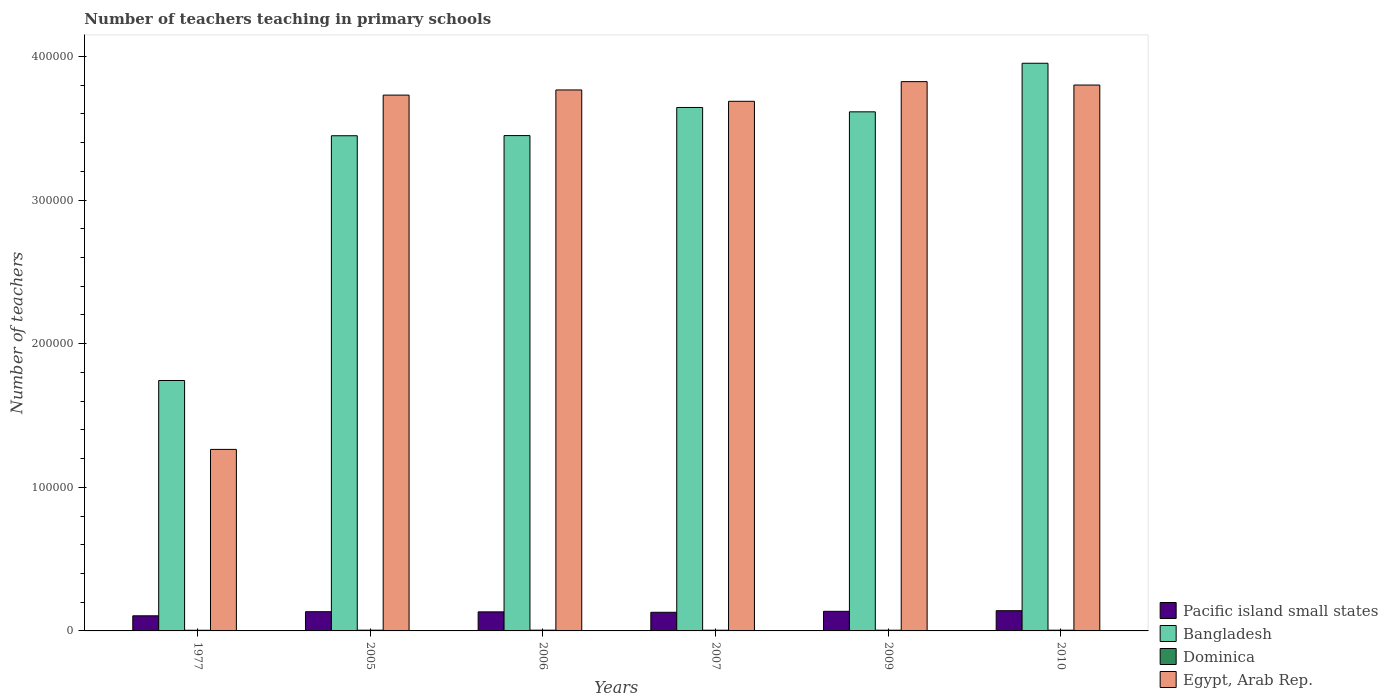How many groups of bars are there?
Provide a short and direct response. 6. Are the number of bars per tick equal to the number of legend labels?
Give a very brief answer. Yes. Are the number of bars on each tick of the X-axis equal?
Your response must be concise. Yes. How many bars are there on the 5th tick from the left?
Your answer should be very brief. 4. What is the label of the 5th group of bars from the left?
Ensure brevity in your answer.  2009. What is the number of teachers teaching in primary schools in Dominica in 2010?
Provide a short and direct response. 508. Across all years, what is the maximum number of teachers teaching in primary schools in Pacific island small states?
Your answer should be very brief. 1.41e+04. Across all years, what is the minimum number of teachers teaching in primary schools in Egypt, Arab Rep.?
Give a very brief answer. 1.26e+05. In which year was the number of teachers teaching in primary schools in Bangladesh maximum?
Keep it short and to the point. 2010. What is the total number of teachers teaching in primary schools in Dominica in the graph?
Provide a short and direct response. 3015. What is the difference between the number of teachers teaching in primary schools in Egypt, Arab Rep. in 1977 and that in 2010?
Keep it short and to the point. -2.54e+05. What is the difference between the number of teachers teaching in primary schools in Egypt, Arab Rep. in 2010 and the number of teachers teaching in primary schools in Pacific island small states in 2009?
Ensure brevity in your answer.  3.66e+05. What is the average number of teachers teaching in primary schools in Pacific island small states per year?
Make the answer very short. 1.30e+04. In the year 2010, what is the difference between the number of teachers teaching in primary schools in Egypt, Arab Rep. and number of teachers teaching in primary schools in Dominica?
Offer a terse response. 3.80e+05. What is the ratio of the number of teachers teaching in primary schools in Pacific island small states in 1977 to that in 2009?
Offer a very short reply. 0.77. Is the number of teachers teaching in primary schools in Dominica in 2006 less than that in 2009?
Your answer should be compact. No. Is the difference between the number of teachers teaching in primary schools in Egypt, Arab Rep. in 2005 and 2010 greater than the difference between the number of teachers teaching in primary schools in Dominica in 2005 and 2010?
Ensure brevity in your answer.  No. What is the difference between the highest and the second highest number of teachers teaching in primary schools in Pacific island small states?
Make the answer very short. 437.17. What is the difference between the highest and the lowest number of teachers teaching in primary schools in Dominica?
Offer a terse response. 57. What does the 1st bar from the left in 2007 represents?
Provide a short and direct response. Pacific island small states. What does the 1st bar from the right in 1977 represents?
Offer a terse response. Egypt, Arab Rep. Is it the case that in every year, the sum of the number of teachers teaching in primary schools in Dominica and number of teachers teaching in primary schools in Egypt, Arab Rep. is greater than the number of teachers teaching in primary schools in Bangladesh?
Give a very brief answer. No. How many bars are there?
Make the answer very short. 24. How many years are there in the graph?
Keep it short and to the point. 6. Does the graph contain any zero values?
Offer a very short reply. No. Where does the legend appear in the graph?
Your response must be concise. Bottom right. How many legend labels are there?
Make the answer very short. 4. How are the legend labels stacked?
Give a very brief answer. Vertical. What is the title of the graph?
Your response must be concise. Number of teachers teaching in primary schools. What is the label or title of the Y-axis?
Your response must be concise. Number of teachers. What is the Number of teachers in Pacific island small states in 1977?
Ensure brevity in your answer.  1.05e+04. What is the Number of teachers of Bangladesh in 1977?
Your answer should be very brief. 1.74e+05. What is the Number of teachers in Dominica in 1977?
Keep it short and to the point. 462. What is the Number of teachers in Egypt, Arab Rep. in 1977?
Your response must be concise. 1.26e+05. What is the Number of teachers of Pacific island small states in 2005?
Provide a succinct answer. 1.34e+04. What is the Number of teachers in Bangladesh in 2005?
Your response must be concise. 3.45e+05. What is the Number of teachers of Dominica in 2005?
Give a very brief answer. 519. What is the Number of teachers in Egypt, Arab Rep. in 2005?
Keep it short and to the point. 3.73e+05. What is the Number of teachers of Pacific island small states in 2006?
Offer a terse response. 1.33e+04. What is the Number of teachers in Bangladesh in 2006?
Make the answer very short. 3.45e+05. What is the Number of teachers in Dominica in 2006?
Provide a succinct answer. 517. What is the Number of teachers of Egypt, Arab Rep. in 2006?
Provide a short and direct response. 3.77e+05. What is the Number of teachers in Pacific island small states in 2007?
Your response must be concise. 1.30e+04. What is the Number of teachers of Bangladesh in 2007?
Your answer should be compact. 3.64e+05. What is the Number of teachers in Dominica in 2007?
Make the answer very short. 499. What is the Number of teachers of Egypt, Arab Rep. in 2007?
Provide a succinct answer. 3.69e+05. What is the Number of teachers in Pacific island small states in 2009?
Provide a short and direct response. 1.36e+04. What is the Number of teachers in Bangladesh in 2009?
Your answer should be compact. 3.61e+05. What is the Number of teachers of Dominica in 2009?
Provide a succinct answer. 510. What is the Number of teachers in Egypt, Arab Rep. in 2009?
Make the answer very short. 3.82e+05. What is the Number of teachers of Pacific island small states in 2010?
Provide a short and direct response. 1.41e+04. What is the Number of teachers of Bangladesh in 2010?
Your response must be concise. 3.95e+05. What is the Number of teachers of Dominica in 2010?
Ensure brevity in your answer.  508. What is the Number of teachers in Egypt, Arab Rep. in 2010?
Ensure brevity in your answer.  3.80e+05. Across all years, what is the maximum Number of teachers of Pacific island small states?
Your response must be concise. 1.41e+04. Across all years, what is the maximum Number of teachers in Bangladesh?
Offer a terse response. 3.95e+05. Across all years, what is the maximum Number of teachers of Dominica?
Keep it short and to the point. 519. Across all years, what is the maximum Number of teachers of Egypt, Arab Rep.?
Make the answer very short. 3.82e+05. Across all years, what is the minimum Number of teachers of Pacific island small states?
Offer a terse response. 1.05e+04. Across all years, what is the minimum Number of teachers in Bangladesh?
Provide a short and direct response. 1.74e+05. Across all years, what is the minimum Number of teachers in Dominica?
Give a very brief answer. 462. Across all years, what is the minimum Number of teachers in Egypt, Arab Rep.?
Offer a very short reply. 1.26e+05. What is the total Number of teachers in Pacific island small states in the graph?
Ensure brevity in your answer.  7.79e+04. What is the total Number of teachers of Bangladesh in the graph?
Give a very brief answer. 1.99e+06. What is the total Number of teachers in Dominica in the graph?
Provide a short and direct response. 3015. What is the total Number of teachers in Egypt, Arab Rep. in the graph?
Your answer should be very brief. 2.01e+06. What is the difference between the Number of teachers in Pacific island small states in 1977 and that in 2005?
Keep it short and to the point. -2846.24. What is the difference between the Number of teachers in Bangladesh in 1977 and that in 2005?
Provide a succinct answer. -1.70e+05. What is the difference between the Number of teachers of Dominica in 1977 and that in 2005?
Offer a terse response. -57. What is the difference between the Number of teachers of Egypt, Arab Rep. in 1977 and that in 2005?
Your answer should be compact. -2.47e+05. What is the difference between the Number of teachers in Pacific island small states in 1977 and that in 2006?
Give a very brief answer. -2742.47. What is the difference between the Number of teachers in Bangladesh in 1977 and that in 2006?
Your answer should be compact. -1.71e+05. What is the difference between the Number of teachers in Dominica in 1977 and that in 2006?
Your answer should be compact. -55. What is the difference between the Number of teachers of Egypt, Arab Rep. in 1977 and that in 2006?
Your answer should be compact. -2.50e+05. What is the difference between the Number of teachers in Pacific island small states in 1977 and that in 2007?
Your response must be concise. -2448.02. What is the difference between the Number of teachers of Bangladesh in 1977 and that in 2007?
Your response must be concise. -1.90e+05. What is the difference between the Number of teachers of Dominica in 1977 and that in 2007?
Offer a very short reply. -37. What is the difference between the Number of teachers in Egypt, Arab Rep. in 1977 and that in 2007?
Your answer should be very brief. -2.42e+05. What is the difference between the Number of teachers of Pacific island small states in 1977 and that in 2009?
Your answer should be compact. -3119.65. What is the difference between the Number of teachers of Bangladesh in 1977 and that in 2009?
Your answer should be very brief. -1.87e+05. What is the difference between the Number of teachers in Dominica in 1977 and that in 2009?
Provide a short and direct response. -48. What is the difference between the Number of teachers of Egypt, Arab Rep. in 1977 and that in 2009?
Provide a short and direct response. -2.56e+05. What is the difference between the Number of teachers of Pacific island small states in 1977 and that in 2010?
Your answer should be compact. -3556.83. What is the difference between the Number of teachers of Bangladesh in 1977 and that in 2010?
Offer a very short reply. -2.21e+05. What is the difference between the Number of teachers of Dominica in 1977 and that in 2010?
Keep it short and to the point. -46. What is the difference between the Number of teachers in Egypt, Arab Rep. in 1977 and that in 2010?
Provide a succinct answer. -2.54e+05. What is the difference between the Number of teachers in Pacific island small states in 2005 and that in 2006?
Your answer should be very brief. 103.77. What is the difference between the Number of teachers in Bangladesh in 2005 and that in 2006?
Ensure brevity in your answer.  -108. What is the difference between the Number of teachers of Dominica in 2005 and that in 2006?
Offer a terse response. 2. What is the difference between the Number of teachers in Egypt, Arab Rep. in 2005 and that in 2006?
Ensure brevity in your answer.  -3594. What is the difference between the Number of teachers in Pacific island small states in 2005 and that in 2007?
Offer a very short reply. 398.22. What is the difference between the Number of teachers in Bangladesh in 2005 and that in 2007?
Ensure brevity in your answer.  -1.97e+04. What is the difference between the Number of teachers in Dominica in 2005 and that in 2007?
Ensure brevity in your answer.  20. What is the difference between the Number of teachers in Egypt, Arab Rep. in 2005 and that in 2007?
Offer a terse response. 4319. What is the difference between the Number of teachers of Pacific island small states in 2005 and that in 2009?
Keep it short and to the point. -273.41. What is the difference between the Number of teachers in Bangladesh in 2005 and that in 2009?
Offer a terse response. -1.66e+04. What is the difference between the Number of teachers of Egypt, Arab Rep. in 2005 and that in 2009?
Ensure brevity in your answer.  -9384. What is the difference between the Number of teachers in Pacific island small states in 2005 and that in 2010?
Give a very brief answer. -710.59. What is the difference between the Number of teachers in Bangladesh in 2005 and that in 2010?
Provide a short and direct response. -5.05e+04. What is the difference between the Number of teachers of Dominica in 2005 and that in 2010?
Give a very brief answer. 11. What is the difference between the Number of teachers of Egypt, Arab Rep. in 2005 and that in 2010?
Ensure brevity in your answer.  -7007. What is the difference between the Number of teachers in Pacific island small states in 2006 and that in 2007?
Give a very brief answer. 294.45. What is the difference between the Number of teachers in Bangladesh in 2006 and that in 2007?
Your response must be concise. -1.96e+04. What is the difference between the Number of teachers in Egypt, Arab Rep. in 2006 and that in 2007?
Provide a short and direct response. 7913. What is the difference between the Number of teachers of Pacific island small states in 2006 and that in 2009?
Ensure brevity in your answer.  -377.18. What is the difference between the Number of teachers of Bangladesh in 2006 and that in 2009?
Offer a terse response. -1.65e+04. What is the difference between the Number of teachers of Egypt, Arab Rep. in 2006 and that in 2009?
Provide a short and direct response. -5790. What is the difference between the Number of teachers of Pacific island small states in 2006 and that in 2010?
Offer a terse response. -814.36. What is the difference between the Number of teachers of Bangladesh in 2006 and that in 2010?
Your answer should be very brief. -5.04e+04. What is the difference between the Number of teachers of Dominica in 2006 and that in 2010?
Your answer should be very brief. 9. What is the difference between the Number of teachers in Egypt, Arab Rep. in 2006 and that in 2010?
Give a very brief answer. -3413. What is the difference between the Number of teachers of Pacific island small states in 2007 and that in 2009?
Your response must be concise. -671.63. What is the difference between the Number of teachers of Bangladesh in 2007 and that in 2009?
Keep it short and to the point. 3044. What is the difference between the Number of teachers in Dominica in 2007 and that in 2009?
Your answer should be compact. -11. What is the difference between the Number of teachers in Egypt, Arab Rep. in 2007 and that in 2009?
Ensure brevity in your answer.  -1.37e+04. What is the difference between the Number of teachers in Pacific island small states in 2007 and that in 2010?
Make the answer very short. -1108.81. What is the difference between the Number of teachers of Bangladesh in 2007 and that in 2010?
Give a very brief answer. -3.08e+04. What is the difference between the Number of teachers of Egypt, Arab Rep. in 2007 and that in 2010?
Your answer should be compact. -1.13e+04. What is the difference between the Number of teachers in Pacific island small states in 2009 and that in 2010?
Keep it short and to the point. -437.17. What is the difference between the Number of teachers in Bangladesh in 2009 and that in 2010?
Provide a succinct answer. -3.38e+04. What is the difference between the Number of teachers in Dominica in 2009 and that in 2010?
Give a very brief answer. 2. What is the difference between the Number of teachers of Egypt, Arab Rep. in 2009 and that in 2010?
Your answer should be compact. 2377. What is the difference between the Number of teachers of Pacific island small states in 1977 and the Number of teachers of Bangladesh in 2005?
Provide a succinct answer. -3.34e+05. What is the difference between the Number of teachers in Pacific island small states in 1977 and the Number of teachers in Dominica in 2005?
Provide a short and direct response. 1.00e+04. What is the difference between the Number of teachers in Pacific island small states in 1977 and the Number of teachers in Egypt, Arab Rep. in 2005?
Offer a very short reply. -3.63e+05. What is the difference between the Number of teachers in Bangladesh in 1977 and the Number of teachers in Dominica in 2005?
Your answer should be very brief. 1.74e+05. What is the difference between the Number of teachers in Bangladesh in 1977 and the Number of teachers in Egypt, Arab Rep. in 2005?
Offer a very short reply. -1.99e+05. What is the difference between the Number of teachers in Dominica in 1977 and the Number of teachers in Egypt, Arab Rep. in 2005?
Ensure brevity in your answer.  -3.73e+05. What is the difference between the Number of teachers of Pacific island small states in 1977 and the Number of teachers of Bangladesh in 2006?
Provide a short and direct response. -3.34e+05. What is the difference between the Number of teachers in Pacific island small states in 1977 and the Number of teachers in Dominica in 2006?
Provide a succinct answer. 1.00e+04. What is the difference between the Number of teachers in Pacific island small states in 1977 and the Number of teachers in Egypt, Arab Rep. in 2006?
Your response must be concise. -3.66e+05. What is the difference between the Number of teachers of Bangladesh in 1977 and the Number of teachers of Dominica in 2006?
Offer a very short reply. 1.74e+05. What is the difference between the Number of teachers of Bangladesh in 1977 and the Number of teachers of Egypt, Arab Rep. in 2006?
Your response must be concise. -2.02e+05. What is the difference between the Number of teachers of Dominica in 1977 and the Number of teachers of Egypt, Arab Rep. in 2006?
Your answer should be very brief. -3.76e+05. What is the difference between the Number of teachers of Pacific island small states in 1977 and the Number of teachers of Bangladesh in 2007?
Your response must be concise. -3.54e+05. What is the difference between the Number of teachers in Pacific island small states in 1977 and the Number of teachers in Dominica in 2007?
Offer a terse response. 1.00e+04. What is the difference between the Number of teachers in Pacific island small states in 1977 and the Number of teachers in Egypt, Arab Rep. in 2007?
Your response must be concise. -3.58e+05. What is the difference between the Number of teachers of Bangladesh in 1977 and the Number of teachers of Dominica in 2007?
Your answer should be compact. 1.74e+05. What is the difference between the Number of teachers in Bangladesh in 1977 and the Number of teachers in Egypt, Arab Rep. in 2007?
Your response must be concise. -1.94e+05. What is the difference between the Number of teachers of Dominica in 1977 and the Number of teachers of Egypt, Arab Rep. in 2007?
Your answer should be very brief. -3.68e+05. What is the difference between the Number of teachers in Pacific island small states in 1977 and the Number of teachers in Bangladesh in 2009?
Ensure brevity in your answer.  -3.51e+05. What is the difference between the Number of teachers in Pacific island small states in 1977 and the Number of teachers in Dominica in 2009?
Provide a short and direct response. 1.00e+04. What is the difference between the Number of teachers of Pacific island small states in 1977 and the Number of teachers of Egypt, Arab Rep. in 2009?
Your response must be concise. -3.72e+05. What is the difference between the Number of teachers of Bangladesh in 1977 and the Number of teachers of Dominica in 2009?
Your response must be concise. 1.74e+05. What is the difference between the Number of teachers in Bangladesh in 1977 and the Number of teachers in Egypt, Arab Rep. in 2009?
Give a very brief answer. -2.08e+05. What is the difference between the Number of teachers of Dominica in 1977 and the Number of teachers of Egypt, Arab Rep. in 2009?
Give a very brief answer. -3.82e+05. What is the difference between the Number of teachers in Pacific island small states in 1977 and the Number of teachers in Bangladesh in 2010?
Ensure brevity in your answer.  -3.85e+05. What is the difference between the Number of teachers of Pacific island small states in 1977 and the Number of teachers of Dominica in 2010?
Your answer should be compact. 1.00e+04. What is the difference between the Number of teachers of Pacific island small states in 1977 and the Number of teachers of Egypt, Arab Rep. in 2010?
Make the answer very short. -3.70e+05. What is the difference between the Number of teachers in Bangladesh in 1977 and the Number of teachers in Dominica in 2010?
Provide a succinct answer. 1.74e+05. What is the difference between the Number of teachers of Bangladesh in 1977 and the Number of teachers of Egypt, Arab Rep. in 2010?
Keep it short and to the point. -2.06e+05. What is the difference between the Number of teachers in Dominica in 1977 and the Number of teachers in Egypt, Arab Rep. in 2010?
Your answer should be very brief. -3.80e+05. What is the difference between the Number of teachers of Pacific island small states in 2005 and the Number of teachers of Bangladesh in 2006?
Ensure brevity in your answer.  -3.32e+05. What is the difference between the Number of teachers of Pacific island small states in 2005 and the Number of teachers of Dominica in 2006?
Your response must be concise. 1.29e+04. What is the difference between the Number of teachers of Pacific island small states in 2005 and the Number of teachers of Egypt, Arab Rep. in 2006?
Your answer should be compact. -3.63e+05. What is the difference between the Number of teachers in Bangladesh in 2005 and the Number of teachers in Dominica in 2006?
Provide a short and direct response. 3.44e+05. What is the difference between the Number of teachers in Bangladesh in 2005 and the Number of teachers in Egypt, Arab Rep. in 2006?
Offer a very short reply. -3.19e+04. What is the difference between the Number of teachers in Dominica in 2005 and the Number of teachers in Egypt, Arab Rep. in 2006?
Make the answer very short. -3.76e+05. What is the difference between the Number of teachers in Pacific island small states in 2005 and the Number of teachers in Bangladesh in 2007?
Give a very brief answer. -3.51e+05. What is the difference between the Number of teachers of Pacific island small states in 2005 and the Number of teachers of Dominica in 2007?
Offer a terse response. 1.29e+04. What is the difference between the Number of teachers in Pacific island small states in 2005 and the Number of teachers in Egypt, Arab Rep. in 2007?
Make the answer very short. -3.55e+05. What is the difference between the Number of teachers in Bangladesh in 2005 and the Number of teachers in Dominica in 2007?
Offer a terse response. 3.44e+05. What is the difference between the Number of teachers in Bangladesh in 2005 and the Number of teachers in Egypt, Arab Rep. in 2007?
Your answer should be compact. -2.40e+04. What is the difference between the Number of teachers of Dominica in 2005 and the Number of teachers of Egypt, Arab Rep. in 2007?
Make the answer very short. -3.68e+05. What is the difference between the Number of teachers in Pacific island small states in 2005 and the Number of teachers in Bangladesh in 2009?
Give a very brief answer. -3.48e+05. What is the difference between the Number of teachers of Pacific island small states in 2005 and the Number of teachers of Dominica in 2009?
Provide a succinct answer. 1.29e+04. What is the difference between the Number of teachers of Pacific island small states in 2005 and the Number of teachers of Egypt, Arab Rep. in 2009?
Provide a succinct answer. -3.69e+05. What is the difference between the Number of teachers of Bangladesh in 2005 and the Number of teachers of Dominica in 2009?
Keep it short and to the point. 3.44e+05. What is the difference between the Number of teachers of Bangladesh in 2005 and the Number of teachers of Egypt, Arab Rep. in 2009?
Provide a short and direct response. -3.77e+04. What is the difference between the Number of teachers in Dominica in 2005 and the Number of teachers in Egypt, Arab Rep. in 2009?
Provide a short and direct response. -3.82e+05. What is the difference between the Number of teachers in Pacific island small states in 2005 and the Number of teachers in Bangladesh in 2010?
Keep it short and to the point. -3.82e+05. What is the difference between the Number of teachers in Pacific island small states in 2005 and the Number of teachers in Dominica in 2010?
Offer a very short reply. 1.29e+04. What is the difference between the Number of teachers in Pacific island small states in 2005 and the Number of teachers in Egypt, Arab Rep. in 2010?
Offer a very short reply. -3.67e+05. What is the difference between the Number of teachers of Bangladesh in 2005 and the Number of teachers of Dominica in 2010?
Offer a very short reply. 3.44e+05. What is the difference between the Number of teachers of Bangladesh in 2005 and the Number of teachers of Egypt, Arab Rep. in 2010?
Your answer should be very brief. -3.53e+04. What is the difference between the Number of teachers of Dominica in 2005 and the Number of teachers of Egypt, Arab Rep. in 2010?
Provide a short and direct response. -3.80e+05. What is the difference between the Number of teachers in Pacific island small states in 2006 and the Number of teachers in Bangladesh in 2007?
Your response must be concise. -3.51e+05. What is the difference between the Number of teachers of Pacific island small states in 2006 and the Number of teachers of Dominica in 2007?
Provide a succinct answer. 1.28e+04. What is the difference between the Number of teachers of Pacific island small states in 2006 and the Number of teachers of Egypt, Arab Rep. in 2007?
Your answer should be very brief. -3.56e+05. What is the difference between the Number of teachers in Bangladesh in 2006 and the Number of teachers in Dominica in 2007?
Your answer should be very brief. 3.44e+05. What is the difference between the Number of teachers of Bangladesh in 2006 and the Number of teachers of Egypt, Arab Rep. in 2007?
Offer a very short reply. -2.39e+04. What is the difference between the Number of teachers in Dominica in 2006 and the Number of teachers in Egypt, Arab Rep. in 2007?
Ensure brevity in your answer.  -3.68e+05. What is the difference between the Number of teachers of Pacific island small states in 2006 and the Number of teachers of Bangladesh in 2009?
Keep it short and to the point. -3.48e+05. What is the difference between the Number of teachers in Pacific island small states in 2006 and the Number of teachers in Dominica in 2009?
Offer a very short reply. 1.28e+04. What is the difference between the Number of teachers in Pacific island small states in 2006 and the Number of teachers in Egypt, Arab Rep. in 2009?
Ensure brevity in your answer.  -3.69e+05. What is the difference between the Number of teachers of Bangladesh in 2006 and the Number of teachers of Dominica in 2009?
Your answer should be compact. 3.44e+05. What is the difference between the Number of teachers of Bangladesh in 2006 and the Number of teachers of Egypt, Arab Rep. in 2009?
Keep it short and to the point. -3.76e+04. What is the difference between the Number of teachers in Dominica in 2006 and the Number of teachers in Egypt, Arab Rep. in 2009?
Offer a very short reply. -3.82e+05. What is the difference between the Number of teachers in Pacific island small states in 2006 and the Number of teachers in Bangladesh in 2010?
Offer a terse response. -3.82e+05. What is the difference between the Number of teachers of Pacific island small states in 2006 and the Number of teachers of Dominica in 2010?
Keep it short and to the point. 1.28e+04. What is the difference between the Number of teachers of Pacific island small states in 2006 and the Number of teachers of Egypt, Arab Rep. in 2010?
Keep it short and to the point. -3.67e+05. What is the difference between the Number of teachers of Bangladesh in 2006 and the Number of teachers of Dominica in 2010?
Provide a short and direct response. 3.44e+05. What is the difference between the Number of teachers in Bangladesh in 2006 and the Number of teachers in Egypt, Arab Rep. in 2010?
Your answer should be very brief. -3.52e+04. What is the difference between the Number of teachers of Dominica in 2006 and the Number of teachers of Egypt, Arab Rep. in 2010?
Keep it short and to the point. -3.80e+05. What is the difference between the Number of teachers of Pacific island small states in 2007 and the Number of teachers of Bangladesh in 2009?
Give a very brief answer. -3.48e+05. What is the difference between the Number of teachers in Pacific island small states in 2007 and the Number of teachers in Dominica in 2009?
Your answer should be compact. 1.25e+04. What is the difference between the Number of teachers of Pacific island small states in 2007 and the Number of teachers of Egypt, Arab Rep. in 2009?
Ensure brevity in your answer.  -3.70e+05. What is the difference between the Number of teachers in Bangladesh in 2007 and the Number of teachers in Dominica in 2009?
Keep it short and to the point. 3.64e+05. What is the difference between the Number of teachers of Bangladesh in 2007 and the Number of teachers of Egypt, Arab Rep. in 2009?
Provide a succinct answer. -1.80e+04. What is the difference between the Number of teachers in Dominica in 2007 and the Number of teachers in Egypt, Arab Rep. in 2009?
Give a very brief answer. -3.82e+05. What is the difference between the Number of teachers of Pacific island small states in 2007 and the Number of teachers of Bangladesh in 2010?
Give a very brief answer. -3.82e+05. What is the difference between the Number of teachers in Pacific island small states in 2007 and the Number of teachers in Dominica in 2010?
Your answer should be compact. 1.25e+04. What is the difference between the Number of teachers in Pacific island small states in 2007 and the Number of teachers in Egypt, Arab Rep. in 2010?
Your answer should be very brief. -3.67e+05. What is the difference between the Number of teachers in Bangladesh in 2007 and the Number of teachers in Dominica in 2010?
Make the answer very short. 3.64e+05. What is the difference between the Number of teachers of Bangladesh in 2007 and the Number of teachers of Egypt, Arab Rep. in 2010?
Keep it short and to the point. -1.56e+04. What is the difference between the Number of teachers in Dominica in 2007 and the Number of teachers in Egypt, Arab Rep. in 2010?
Provide a short and direct response. -3.80e+05. What is the difference between the Number of teachers of Pacific island small states in 2009 and the Number of teachers of Bangladesh in 2010?
Your response must be concise. -3.82e+05. What is the difference between the Number of teachers of Pacific island small states in 2009 and the Number of teachers of Dominica in 2010?
Your response must be concise. 1.31e+04. What is the difference between the Number of teachers in Pacific island small states in 2009 and the Number of teachers in Egypt, Arab Rep. in 2010?
Offer a terse response. -3.66e+05. What is the difference between the Number of teachers of Bangladesh in 2009 and the Number of teachers of Dominica in 2010?
Keep it short and to the point. 3.61e+05. What is the difference between the Number of teachers in Bangladesh in 2009 and the Number of teachers in Egypt, Arab Rep. in 2010?
Provide a short and direct response. -1.87e+04. What is the difference between the Number of teachers in Dominica in 2009 and the Number of teachers in Egypt, Arab Rep. in 2010?
Keep it short and to the point. -3.80e+05. What is the average Number of teachers of Pacific island small states per year?
Offer a very short reply. 1.30e+04. What is the average Number of teachers in Bangladesh per year?
Offer a terse response. 3.31e+05. What is the average Number of teachers in Dominica per year?
Make the answer very short. 502.5. What is the average Number of teachers of Egypt, Arab Rep. per year?
Your answer should be compact. 3.35e+05. In the year 1977, what is the difference between the Number of teachers of Pacific island small states and Number of teachers of Bangladesh?
Your answer should be very brief. -1.64e+05. In the year 1977, what is the difference between the Number of teachers of Pacific island small states and Number of teachers of Dominica?
Your answer should be very brief. 1.01e+04. In the year 1977, what is the difference between the Number of teachers of Pacific island small states and Number of teachers of Egypt, Arab Rep.?
Provide a short and direct response. -1.16e+05. In the year 1977, what is the difference between the Number of teachers of Bangladesh and Number of teachers of Dominica?
Provide a short and direct response. 1.74e+05. In the year 1977, what is the difference between the Number of teachers in Bangladesh and Number of teachers in Egypt, Arab Rep.?
Make the answer very short. 4.80e+04. In the year 1977, what is the difference between the Number of teachers in Dominica and Number of teachers in Egypt, Arab Rep.?
Your response must be concise. -1.26e+05. In the year 2005, what is the difference between the Number of teachers in Pacific island small states and Number of teachers in Bangladesh?
Make the answer very short. -3.31e+05. In the year 2005, what is the difference between the Number of teachers of Pacific island small states and Number of teachers of Dominica?
Offer a very short reply. 1.29e+04. In the year 2005, what is the difference between the Number of teachers of Pacific island small states and Number of teachers of Egypt, Arab Rep.?
Your answer should be very brief. -3.60e+05. In the year 2005, what is the difference between the Number of teachers of Bangladesh and Number of teachers of Dominica?
Provide a succinct answer. 3.44e+05. In the year 2005, what is the difference between the Number of teachers in Bangladesh and Number of teachers in Egypt, Arab Rep.?
Make the answer very short. -2.83e+04. In the year 2005, what is the difference between the Number of teachers in Dominica and Number of teachers in Egypt, Arab Rep.?
Offer a very short reply. -3.73e+05. In the year 2006, what is the difference between the Number of teachers in Pacific island small states and Number of teachers in Bangladesh?
Offer a very short reply. -3.32e+05. In the year 2006, what is the difference between the Number of teachers in Pacific island small states and Number of teachers in Dominica?
Your answer should be very brief. 1.28e+04. In the year 2006, what is the difference between the Number of teachers in Pacific island small states and Number of teachers in Egypt, Arab Rep.?
Your answer should be very brief. -3.63e+05. In the year 2006, what is the difference between the Number of teachers of Bangladesh and Number of teachers of Dominica?
Provide a short and direct response. 3.44e+05. In the year 2006, what is the difference between the Number of teachers of Bangladesh and Number of teachers of Egypt, Arab Rep.?
Offer a terse response. -3.18e+04. In the year 2006, what is the difference between the Number of teachers in Dominica and Number of teachers in Egypt, Arab Rep.?
Offer a very short reply. -3.76e+05. In the year 2007, what is the difference between the Number of teachers of Pacific island small states and Number of teachers of Bangladesh?
Your answer should be very brief. -3.52e+05. In the year 2007, what is the difference between the Number of teachers in Pacific island small states and Number of teachers in Dominica?
Ensure brevity in your answer.  1.25e+04. In the year 2007, what is the difference between the Number of teachers of Pacific island small states and Number of teachers of Egypt, Arab Rep.?
Offer a terse response. -3.56e+05. In the year 2007, what is the difference between the Number of teachers in Bangladesh and Number of teachers in Dominica?
Your answer should be very brief. 3.64e+05. In the year 2007, what is the difference between the Number of teachers of Bangladesh and Number of teachers of Egypt, Arab Rep.?
Make the answer very short. -4291. In the year 2007, what is the difference between the Number of teachers of Dominica and Number of teachers of Egypt, Arab Rep.?
Keep it short and to the point. -3.68e+05. In the year 2009, what is the difference between the Number of teachers in Pacific island small states and Number of teachers in Bangladesh?
Ensure brevity in your answer.  -3.48e+05. In the year 2009, what is the difference between the Number of teachers in Pacific island small states and Number of teachers in Dominica?
Keep it short and to the point. 1.31e+04. In the year 2009, what is the difference between the Number of teachers of Pacific island small states and Number of teachers of Egypt, Arab Rep.?
Provide a short and direct response. -3.69e+05. In the year 2009, what is the difference between the Number of teachers in Bangladesh and Number of teachers in Dominica?
Offer a very short reply. 3.61e+05. In the year 2009, what is the difference between the Number of teachers of Bangladesh and Number of teachers of Egypt, Arab Rep.?
Ensure brevity in your answer.  -2.10e+04. In the year 2009, what is the difference between the Number of teachers in Dominica and Number of teachers in Egypt, Arab Rep.?
Your answer should be compact. -3.82e+05. In the year 2010, what is the difference between the Number of teachers in Pacific island small states and Number of teachers in Bangladesh?
Your answer should be very brief. -3.81e+05. In the year 2010, what is the difference between the Number of teachers of Pacific island small states and Number of teachers of Dominica?
Ensure brevity in your answer.  1.36e+04. In the year 2010, what is the difference between the Number of teachers of Pacific island small states and Number of teachers of Egypt, Arab Rep.?
Your answer should be compact. -3.66e+05. In the year 2010, what is the difference between the Number of teachers of Bangladesh and Number of teachers of Dominica?
Your response must be concise. 3.95e+05. In the year 2010, what is the difference between the Number of teachers in Bangladesh and Number of teachers in Egypt, Arab Rep.?
Your answer should be very brief. 1.52e+04. In the year 2010, what is the difference between the Number of teachers in Dominica and Number of teachers in Egypt, Arab Rep.?
Your answer should be very brief. -3.80e+05. What is the ratio of the Number of teachers in Pacific island small states in 1977 to that in 2005?
Provide a succinct answer. 0.79. What is the ratio of the Number of teachers in Bangladesh in 1977 to that in 2005?
Your answer should be compact. 0.51. What is the ratio of the Number of teachers of Dominica in 1977 to that in 2005?
Your answer should be very brief. 0.89. What is the ratio of the Number of teachers in Egypt, Arab Rep. in 1977 to that in 2005?
Your answer should be compact. 0.34. What is the ratio of the Number of teachers in Pacific island small states in 1977 to that in 2006?
Offer a terse response. 0.79. What is the ratio of the Number of teachers of Bangladesh in 1977 to that in 2006?
Give a very brief answer. 0.51. What is the ratio of the Number of teachers in Dominica in 1977 to that in 2006?
Provide a short and direct response. 0.89. What is the ratio of the Number of teachers of Egypt, Arab Rep. in 1977 to that in 2006?
Ensure brevity in your answer.  0.34. What is the ratio of the Number of teachers in Pacific island small states in 1977 to that in 2007?
Your answer should be compact. 0.81. What is the ratio of the Number of teachers of Bangladesh in 1977 to that in 2007?
Your answer should be compact. 0.48. What is the ratio of the Number of teachers of Dominica in 1977 to that in 2007?
Offer a very short reply. 0.93. What is the ratio of the Number of teachers in Egypt, Arab Rep. in 1977 to that in 2007?
Offer a terse response. 0.34. What is the ratio of the Number of teachers of Pacific island small states in 1977 to that in 2009?
Provide a short and direct response. 0.77. What is the ratio of the Number of teachers in Bangladesh in 1977 to that in 2009?
Your answer should be compact. 0.48. What is the ratio of the Number of teachers in Dominica in 1977 to that in 2009?
Your response must be concise. 0.91. What is the ratio of the Number of teachers in Egypt, Arab Rep. in 1977 to that in 2009?
Make the answer very short. 0.33. What is the ratio of the Number of teachers of Pacific island small states in 1977 to that in 2010?
Keep it short and to the point. 0.75. What is the ratio of the Number of teachers of Bangladesh in 1977 to that in 2010?
Your answer should be compact. 0.44. What is the ratio of the Number of teachers of Dominica in 1977 to that in 2010?
Provide a short and direct response. 0.91. What is the ratio of the Number of teachers in Egypt, Arab Rep. in 1977 to that in 2010?
Your answer should be very brief. 0.33. What is the ratio of the Number of teachers in Pacific island small states in 2005 to that in 2006?
Your response must be concise. 1.01. What is the ratio of the Number of teachers in Bangladesh in 2005 to that in 2006?
Provide a succinct answer. 1. What is the ratio of the Number of teachers of Dominica in 2005 to that in 2006?
Your answer should be very brief. 1. What is the ratio of the Number of teachers in Egypt, Arab Rep. in 2005 to that in 2006?
Give a very brief answer. 0.99. What is the ratio of the Number of teachers of Pacific island small states in 2005 to that in 2007?
Ensure brevity in your answer.  1.03. What is the ratio of the Number of teachers of Bangladesh in 2005 to that in 2007?
Make the answer very short. 0.95. What is the ratio of the Number of teachers of Dominica in 2005 to that in 2007?
Provide a succinct answer. 1.04. What is the ratio of the Number of teachers in Egypt, Arab Rep. in 2005 to that in 2007?
Give a very brief answer. 1.01. What is the ratio of the Number of teachers in Pacific island small states in 2005 to that in 2009?
Offer a terse response. 0.98. What is the ratio of the Number of teachers in Bangladesh in 2005 to that in 2009?
Your response must be concise. 0.95. What is the ratio of the Number of teachers of Dominica in 2005 to that in 2009?
Offer a terse response. 1.02. What is the ratio of the Number of teachers of Egypt, Arab Rep. in 2005 to that in 2009?
Offer a very short reply. 0.98. What is the ratio of the Number of teachers in Pacific island small states in 2005 to that in 2010?
Provide a succinct answer. 0.95. What is the ratio of the Number of teachers in Bangladesh in 2005 to that in 2010?
Your answer should be very brief. 0.87. What is the ratio of the Number of teachers of Dominica in 2005 to that in 2010?
Give a very brief answer. 1.02. What is the ratio of the Number of teachers in Egypt, Arab Rep. in 2005 to that in 2010?
Offer a terse response. 0.98. What is the ratio of the Number of teachers of Pacific island small states in 2006 to that in 2007?
Make the answer very short. 1.02. What is the ratio of the Number of teachers of Bangladesh in 2006 to that in 2007?
Keep it short and to the point. 0.95. What is the ratio of the Number of teachers of Dominica in 2006 to that in 2007?
Your answer should be very brief. 1.04. What is the ratio of the Number of teachers of Egypt, Arab Rep. in 2006 to that in 2007?
Give a very brief answer. 1.02. What is the ratio of the Number of teachers in Pacific island small states in 2006 to that in 2009?
Your answer should be compact. 0.97. What is the ratio of the Number of teachers of Bangladesh in 2006 to that in 2009?
Your answer should be very brief. 0.95. What is the ratio of the Number of teachers of Dominica in 2006 to that in 2009?
Ensure brevity in your answer.  1.01. What is the ratio of the Number of teachers in Egypt, Arab Rep. in 2006 to that in 2009?
Offer a very short reply. 0.98. What is the ratio of the Number of teachers of Pacific island small states in 2006 to that in 2010?
Ensure brevity in your answer.  0.94. What is the ratio of the Number of teachers of Bangladesh in 2006 to that in 2010?
Ensure brevity in your answer.  0.87. What is the ratio of the Number of teachers of Dominica in 2006 to that in 2010?
Your response must be concise. 1.02. What is the ratio of the Number of teachers in Egypt, Arab Rep. in 2006 to that in 2010?
Your response must be concise. 0.99. What is the ratio of the Number of teachers of Pacific island small states in 2007 to that in 2009?
Offer a terse response. 0.95. What is the ratio of the Number of teachers in Bangladesh in 2007 to that in 2009?
Provide a succinct answer. 1.01. What is the ratio of the Number of teachers in Dominica in 2007 to that in 2009?
Your response must be concise. 0.98. What is the ratio of the Number of teachers of Egypt, Arab Rep. in 2007 to that in 2009?
Make the answer very short. 0.96. What is the ratio of the Number of teachers in Pacific island small states in 2007 to that in 2010?
Give a very brief answer. 0.92. What is the ratio of the Number of teachers of Bangladesh in 2007 to that in 2010?
Ensure brevity in your answer.  0.92. What is the ratio of the Number of teachers in Dominica in 2007 to that in 2010?
Ensure brevity in your answer.  0.98. What is the ratio of the Number of teachers in Egypt, Arab Rep. in 2007 to that in 2010?
Your answer should be compact. 0.97. What is the ratio of the Number of teachers of Bangladesh in 2009 to that in 2010?
Offer a very short reply. 0.91. What is the ratio of the Number of teachers in Egypt, Arab Rep. in 2009 to that in 2010?
Your answer should be compact. 1.01. What is the difference between the highest and the second highest Number of teachers of Pacific island small states?
Make the answer very short. 437.17. What is the difference between the highest and the second highest Number of teachers in Bangladesh?
Your answer should be compact. 3.08e+04. What is the difference between the highest and the second highest Number of teachers in Dominica?
Your answer should be very brief. 2. What is the difference between the highest and the second highest Number of teachers of Egypt, Arab Rep.?
Provide a succinct answer. 2377. What is the difference between the highest and the lowest Number of teachers of Pacific island small states?
Your answer should be very brief. 3556.83. What is the difference between the highest and the lowest Number of teachers in Bangladesh?
Provide a succinct answer. 2.21e+05. What is the difference between the highest and the lowest Number of teachers of Dominica?
Your response must be concise. 57. What is the difference between the highest and the lowest Number of teachers of Egypt, Arab Rep.?
Provide a succinct answer. 2.56e+05. 